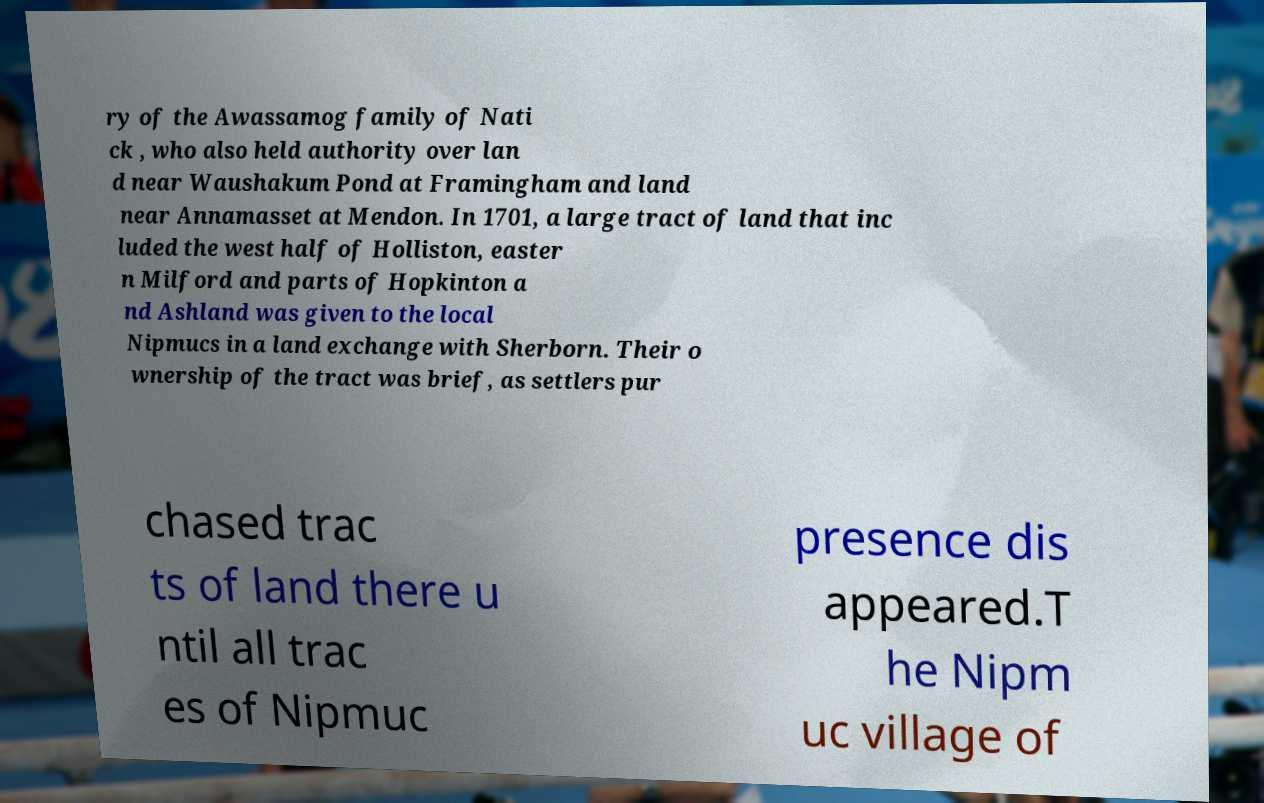There's text embedded in this image that I need extracted. Can you transcribe it verbatim? ry of the Awassamog family of Nati ck , who also held authority over lan d near Waushakum Pond at Framingham and land near Annamasset at Mendon. In 1701, a large tract of land that inc luded the west half of Holliston, easter n Milford and parts of Hopkinton a nd Ashland was given to the local Nipmucs in a land exchange with Sherborn. Their o wnership of the tract was brief, as settlers pur chased trac ts of land there u ntil all trac es of Nipmuc presence dis appeared.T he Nipm uc village of 